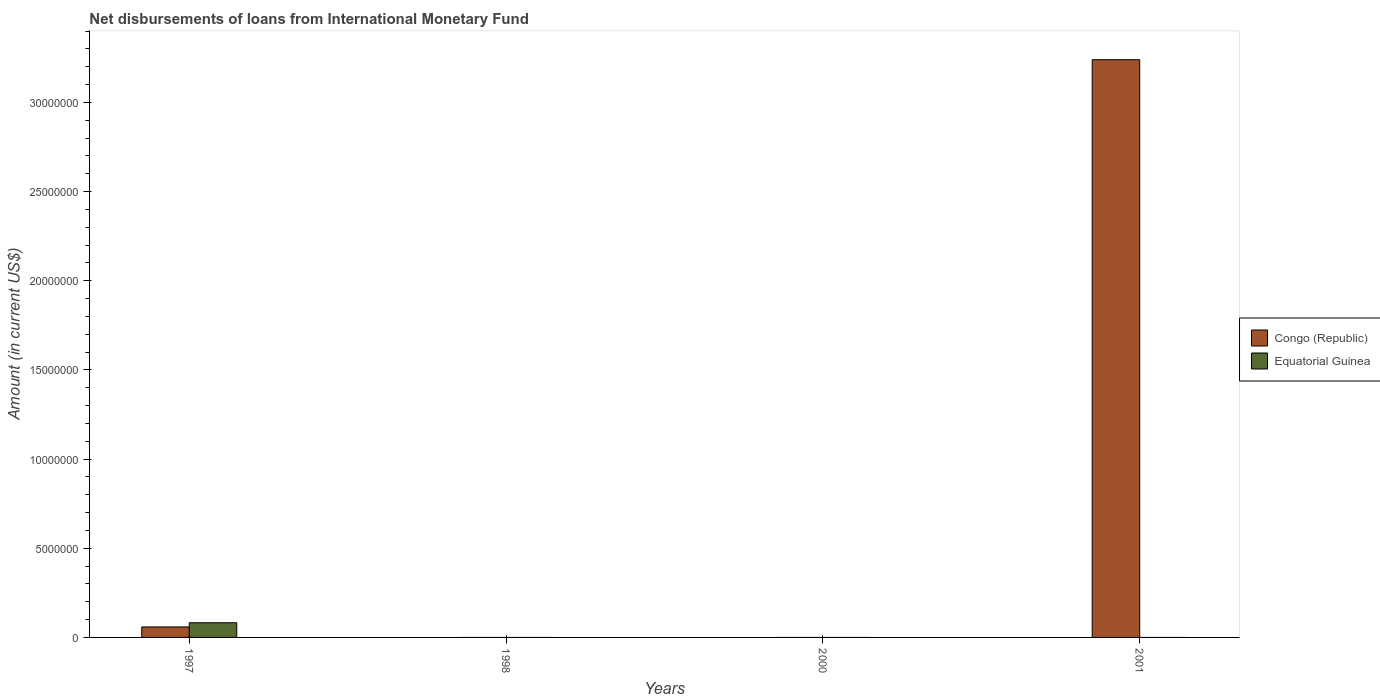How many different coloured bars are there?
Give a very brief answer. 2. Are the number of bars per tick equal to the number of legend labels?
Make the answer very short. No. What is the label of the 2nd group of bars from the left?
Offer a very short reply. 1998. In how many cases, is the number of bars for a given year not equal to the number of legend labels?
Offer a terse response. 3. Across all years, what is the maximum amount of loans disbursed in Equatorial Guinea?
Provide a short and direct response. 8.23e+05. In which year was the amount of loans disbursed in Congo (Republic) maximum?
Ensure brevity in your answer.  2001. What is the total amount of loans disbursed in Congo (Republic) in the graph?
Your answer should be compact. 3.30e+07. What is the difference between the amount of loans disbursed in Congo (Republic) in 1997 and that in 2001?
Offer a very short reply. -3.18e+07. What is the average amount of loans disbursed in Equatorial Guinea per year?
Offer a very short reply. 2.06e+05. In the year 1997, what is the difference between the amount of loans disbursed in Equatorial Guinea and amount of loans disbursed in Congo (Republic)?
Make the answer very short. 2.34e+05. In how many years, is the amount of loans disbursed in Congo (Republic) greater than 2000000 US$?
Provide a short and direct response. 1. What is the difference between the highest and the lowest amount of loans disbursed in Congo (Republic)?
Provide a succinct answer. 3.24e+07. What is the difference between two consecutive major ticks on the Y-axis?
Your answer should be compact. 5.00e+06. Does the graph contain grids?
Make the answer very short. No. Where does the legend appear in the graph?
Make the answer very short. Center right. What is the title of the graph?
Keep it short and to the point. Net disbursements of loans from International Monetary Fund. What is the label or title of the X-axis?
Give a very brief answer. Years. What is the label or title of the Y-axis?
Keep it short and to the point. Amount (in current US$). What is the Amount (in current US$) of Congo (Republic) in 1997?
Make the answer very short. 5.89e+05. What is the Amount (in current US$) of Equatorial Guinea in 1997?
Give a very brief answer. 8.23e+05. What is the Amount (in current US$) in Congo (Republic) in 2001?
Keep it short and to the point. 3.24e+07. What is the Amount (in current US$) in Equatorial Guinea in 2001?
Keep it short and to the point. 0. Across all years, what is the maximum Amount (in current US$) in Congo (Republic)?
Keep it short and to the point. 3.24e+07. Across all years, what is the maximum Amount (in current US$) in Equatorial Guinea?
Offer a very short reply. 8.23e+05. Across all years, what is the minimum Amount (in current US$) of Congo (Republic)?
Your answer should be compact. 0. What is the total Amount (in current US$) of Congo (Republic) in the graph?
Ensure brevity in your answer.  3.30e+07. What is the total Amount (in current US$) of Equatorial Guinea in the graph?
Your answer should be very brief. 8.23e+05. What is the difference between the Amount (in current US$) of Congo (Republic) in 1997 and that in 2001?
Offer a terse response. -3.18e+07. What is the average Amount (in current US$) in Congo (Republic) per year?
Your answer should be compact. 8.25e+06. What is the average Amount (in current US$) in Equatorial Guinea per year?
Keep it short and to the point. 2.06e+05. In the year 1997, what is the difference between the Amount (in current US$) of Congo (Republic) and Amount (in current US$) of Equatorial Guinea?
Your answer should be compact. -2.34e+05. What is the ratio of the Amount (in current US$) of Congo (Republic) in 1997 to that in 2001?
Offer a terse response. 0.02. What is the difference between the highest and the lowest Amount (in current US$) in Congo (Republic)?
Keep it short and to the point. 3.24e+07. What is the difference between the highest and the lowest Amount (in current US$) in Equatorial Guinea?
Ensure brevity in your answer.  8.23e+05. 